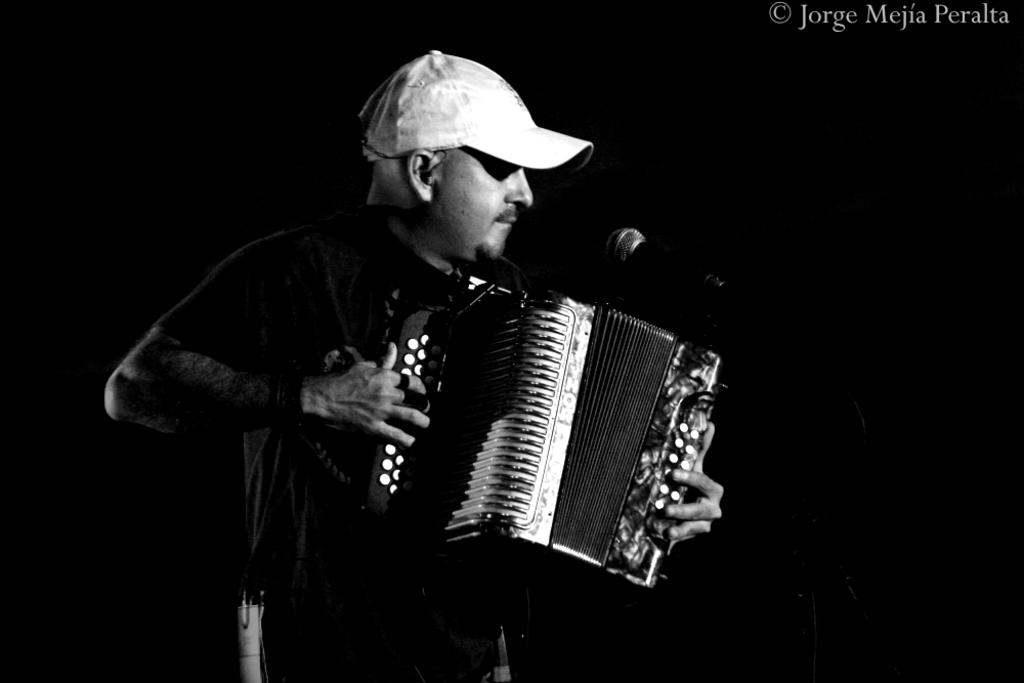What is the main subject of the image? There is a person in the image. What is the person doing in the image? The person is standing and playing a musical instrument. What is in front of the person? There is a microphone in front of the person. What can be observed about the background of the image? The background of the image is dark. Can you see any pencils being used by the person in the image? There are no pencils visible in the image. Is there a monkey playing a musical instrument alongside the person in the image? There is no monkey present in the image; only the person is visible. 